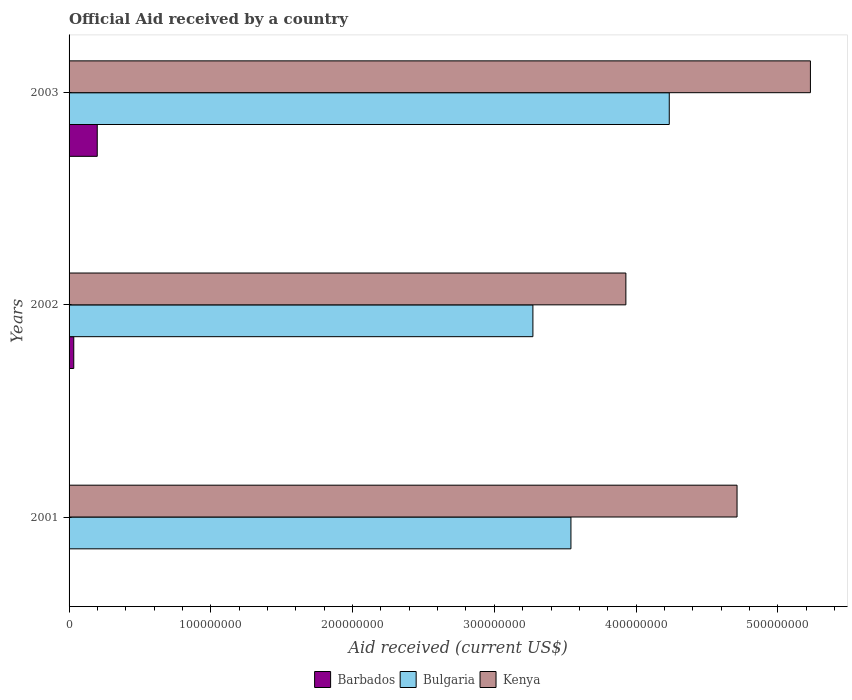How many different coloured bars are there?
Give a very brief answer. 3. How many bars are there on the 3rd tick from the top?
Offer a terse response. 2. What is the label of the 1st group of bars from the top?
Offer a terse response. 2003. In how many cases, is the number of bars for a given year not equal to the number of legend labels?
Your answer should be compact. 1. What is the net official aid received in Bulgaria in 2003?
Give a very brief answer. 4.23e+08. Across all years, what is the maximum net official aid received in Bulgaria?
Give a very brief answer. 4.23e+08. Across all years, what is the minimum net official aid received in Barbados?
Provide a short and direct response. 0. What is the total net official aid received in Kenya in the graph?
Ensure brevity in your answer.  1.39e+09. What is the difference between the net official aid received in Kenya in 2001 and that in 2002?
Your answer should be very brief. 7.84e+07. What is the difference between the net official aid received in Bulgaria in 2001 and the net official aid received in Barbados in 2002?
Keep it short and to the point. 3.51e+08. What is the average net official aid received in Kenya per year?
Offer a very short reply. 4.62e+08. In the year 2003, what is the difference between the net official aid received in Barbados and net official aid received in Bulgaria?
Your answer should be very brief. -4.04e+08. What is the ratio of the net official aid received in Kenya in 2001 to that in 2002?
Your answer should be compact. 1.2. What is the difference between the highest and the second highest net official aid received in Bulgaria?
Offer a very short reply. 6.94e+07. What is the difference between the highest and the lowest net official aid received in Kenya?
Make the answer very short. 1.30e+08. Is the sum of the net official aid received in Bulgaria in 2001 and 2002 greater than the maximum net official aid received in Barbados across all years?
Keep it short and to the point. Yes. How many bars are there?
Provide a succinct answer. 8. How many years are there in the graph?
Keep it short and to the point. 3. Are the values on the major ticks of X-axis written in scientific E-notation?
Provide a succinct answer. No. Does the graph contain grids?
Your answer should be compact. No. Where does the legend appear in the graph?
Provide a succinct answer. Bottom center. How many legend labels are there?
Ensure brevity in your answer.  3. How are the legend labels stacked?
Ensure brevity in your answer.  Horizontal. What is the title of the graph?
Offer a very short reply. Official Aid received by a country. Does "Barbados" appear as one of the legend labels in the graph?
Give a very brief answer. Yes. What is the label or title of the X-axis?
Offer a terse response. Aid received (current US$). What is the label or title of the Y-axis?
Make the answer very short. Years. What is the Aid received (current US$) in Barbados in 2001?
Your response must be concise. 0. What is the Aid received (current US$) in Bulgaria in 2001?
Offer a terse response. 3.54e+08. What is the Aid received (current US$) of Kenya in 2001?
Your answer should be very brief. 4.71e+08. What is the Aid received (current US$) in Barbados in 2002?
Provide a succinct answer. 3.31e+06. What is the Aid received (current US$) of Bulgaria in 2002?
Your response must be concise. 3.27e+08. What is the Aid received (current US$) of Kenya in 2002?
Make the answer very short. 3.93e+08. What is the Aid received (current US$) of Barbados in 2003?
Provide a short and direct response. 1.99e+07. What is the Aid received (current US$) in Bulgaria in 2003?
Your answer should be compact. 4.23e+08. What is the Aid received (current US$) of Kenya in 2003?
Ensure brevity in your answer.  5.23e+08. Across all years, what is the maximum Aid received (current US$) of Barbados?
Your answer should be compact. 1.99e+07. Across all years, what is the maximum Aid received (current US$) of Bulgaria?
Your answer should be very brief. 4.23e+08. Across all years, what is the maximum Aid received (current US$) of Kenya?
Your response must be concise. 5.23e+08. Across all years, what is the minimum Aid received (current US$) of Bulgaria?
Offer a very short reply. 3.27e+08. Across all years, what is the minimum Aid received (current US$) of Kenya?
Offer a very short reply. 3.93e+08. What is the total Aid received (current US$) of Barbados in the graph?
Offer a very short reply. 2.32e+07. What is the total Aid received (current US$) of Bulgaria in the graph?
Ensure brevity in your answer.  1.10e+09. What is the total Aid received (current US$) of Kenya in the graph?
Make the answer very short. 1.39e+09. What is the difference between the Aid received (current US$) of Bulgaria in 2001 and that in 2002?
Offer a terse response. 2.68e+07. What is the difference between the Aid received (current US$) in Kenya in 2001 and that in 2002?
Give a very brief answer. 7.84e+07. What is the difference between the Aid received (current US$) in Bulgaria in 2001 and that in 2003?
Make the answer very short. -6.94e+07. What is the difference between the Aid received (current US$) of Kenya in 2001 and that in 2003?
Offer a terse response. -5.18e+07. What is the difference between the Aid received (current US$) of Barbados in 2002 and that in 2003?
Offer a very short reply. -1.66e+07. What is the difference between the Aid received (current US$) in Bulgaria in 2002 and that in 2003?
Provide a succinct answer. -9.62e+07. What is the difference between the Aid received (current US$) of Kenya in 2002 and that in 2003?
Keep it short and to the point. -1.30e+08. What is the difference between the Aid received (current US$) of Bulgaria in 2001 and the Aid received (current US$) of Kenya in 2002?
Offer a very short reply. -3.88e+07. What is the difference between the Aid received (current US$) in Bulgaria in 2001 and the Aid received (current US$) in Kenya in 2003?
Keep it short and to the point. -1.69e+08. What is the difference between the Aid received (current US$) of Barbados in 2002 and the Aid received (current US$) of Bulgaria in 2003?
Provide a succinct answer. -4.20e+08. What is the difference between the Aid received (current US$) in Barbados in 2002 and the Aid received (current US$) in Kenya in 2003?
Offer a very short reply. -5.20e+08. What is the difference between the Aid received (current US$) of Bulgaria in 2002 and the Aid received (current US$) of Kenya in 2003?
Provide a succinct answer. -1.96e+08. What is the average Aid received (current US$) of Barbados per year?
Make the answer very short. 7.73e+06. What is the average Aid received (current US$) of Bulgaria per year?
Your response must be concise. 3.68e+08. What is the average Aid received (current US$) of Kenya per year?
Offer a very short reply. 4.62e+08. In the year 2001, what is the difference between the Aid received (current US$) in Bulgaria and Aid received (current US$) in Kenya?
Ensure brevity in your answer.  -1.17e+08. In the year 2002, what is the difference between the Aid received (current US$) in Barbados and Aid received (current US$) in Bulgaria?
Your response must be concise. -3.24e+08. In the year 2002, what is the difference between the Aid received (current US$) of Barbados and Aid received (current US$) of Kenya?
Offer a terse response. -3.90e+08. In the year 2002, what is the difference between the Aid received (current US$) of Bulgaria and Aid received (current US$) of Kenya?
Provide a short and direct response. -6.56e+07. In the year 2003, what is the difference between the Aid received (current US$) of Barbados and Aid received (current US$) of Bulgaria?
Offer a very short reply. -4.04e+08. In the year 2003, what is the difference between the Aid received (current US$) in Barbados and Aid received (current US$) in Kenya?
Keep it short and to the point. -5.03e+08. In the year 2003, what is the difference between the Aid received (current US$) in Bulgaria and Aid received (current US$) in Kenya?
Your answer should be very brief. -9.96e+07. What is the ratio of the Aid received (current US$) in Bulgaria in 2001 to that in 2002?
Provide a short and direct response. 1.08. What is the ratio of the Aid received (current US$) of Kenya in 2001 to that in 2002?
Your answer should be compact. 1.2. What is the ratio of the Aid received (current US$) in Bulgaria in 2001 to that in 2003?
Make the answer very short. 0.84. What is the ratio of the Aid received (current US$) of Kenya in 2001 to that in 2003?
Your answer should be compact. 0.9. What is the ratio of the Aid received (current US$) of Barbados in 2002 to that in 2003?
Give a very brief answer. 0.17. What is the ratio of the Aid received (current US$) of Bulgaria in 2002 to that in 2003?
Make the answer very short. 0.77. What is the ratio of the Aid received (current US$) of Kenya in 2002 to that in 2003?
Your response must be concise. 0.75. What is the difference between the highest and the second highest Aid received (current US$) in Bulgaria?
Keep it short and to the point. 6.94e+07. What is the difference between the highest and the second highest Aid received (current US$) in Kenya?
Provide a short and direct response. 5.18e+07. What is the difference between the highest and the lowest Aid received (current US$) in Barbados?
Make the answer very short. 1.99e+07. What is the difference between the highest and the lowest Aid received (current US$) of Bulgaria?
Give a very brief answer. 9.62e+07. What is the difference between the highest and the lowest Aid received (current US$) in Kenya?
Ensure brevity in your answer.  1.30e+08. 